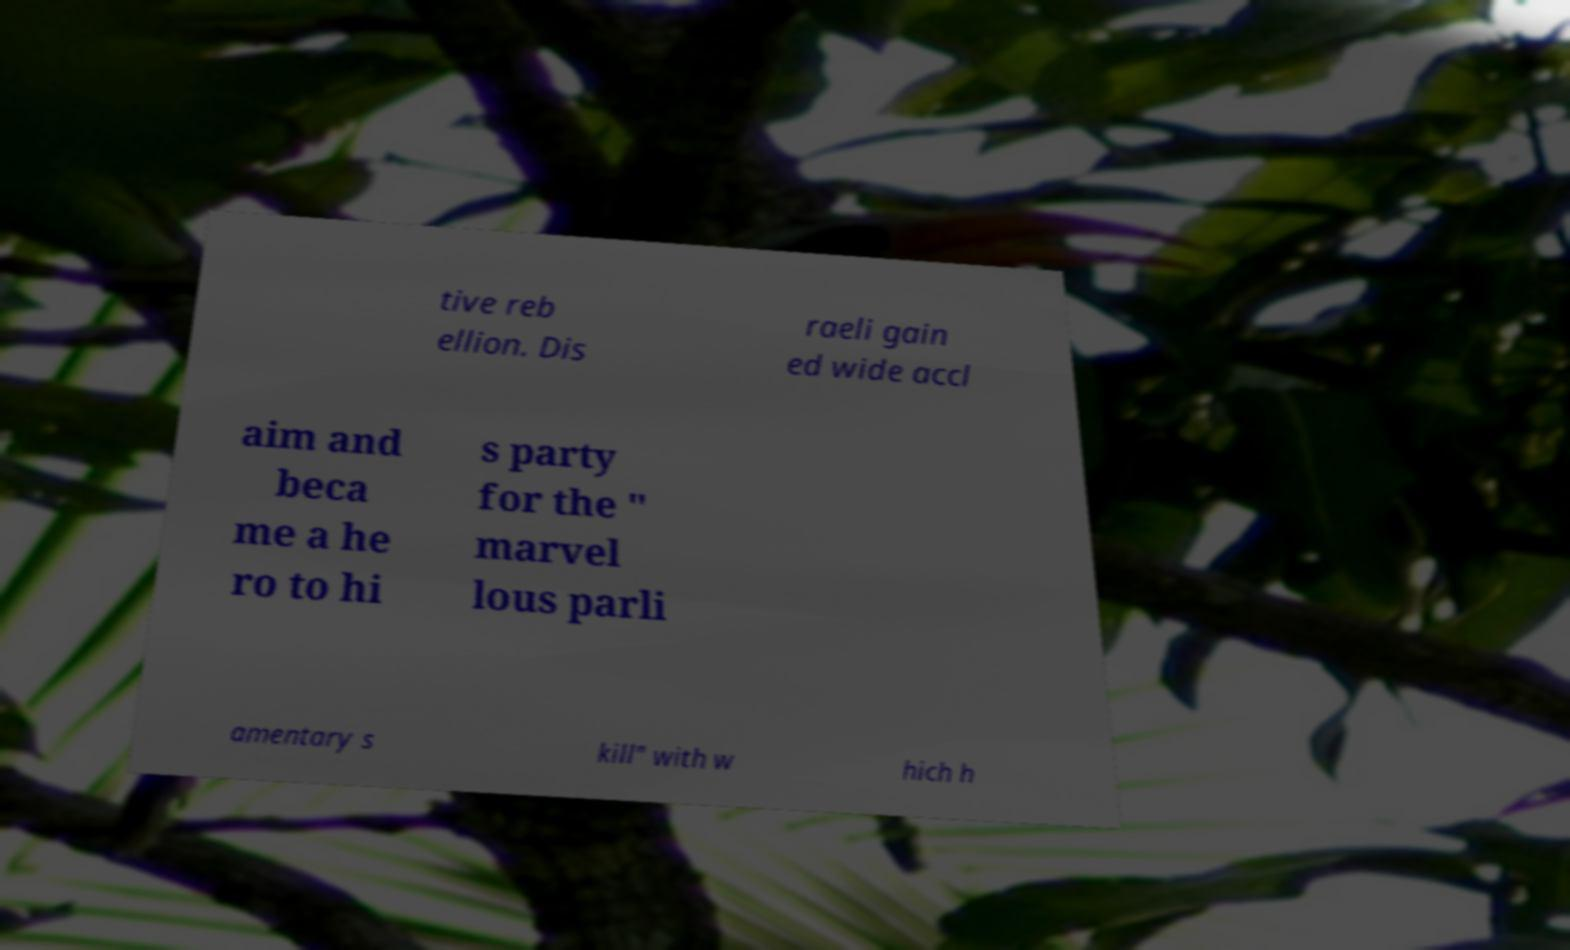Could you extract and type out the text from this image? tive reb ellion. Dis raeli gain ed wide accl aim and beca me a he ro to hi s party for the " marvel lous parli amentary s kill" with w hich h 